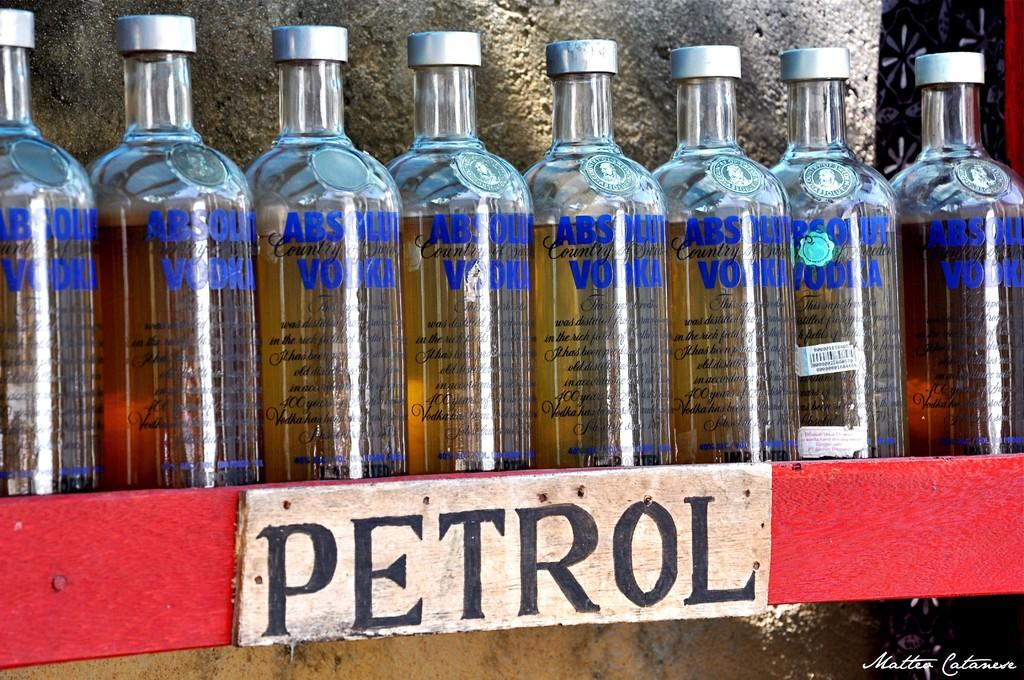<image>
Describe the image concisely. Several bottles of Absolut vodka sit on a shelf above a sign that reads Petrol. 